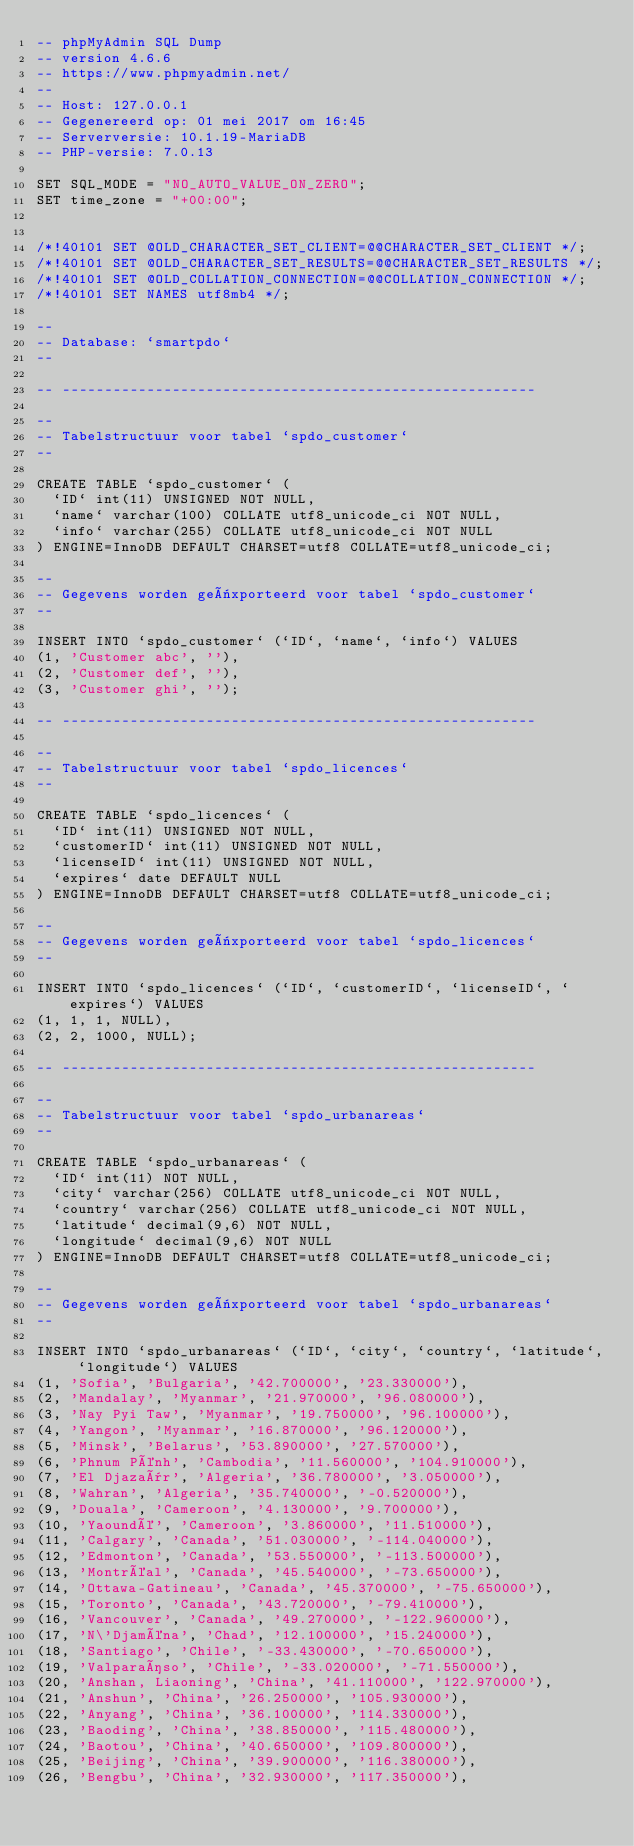<code> <loc_0><loc_0><loc_500><loc_500><_SQL_>-- phpMyAdmin SQL Dump
-- version 4.6.6
-- https://www.phpmyadmin.net/
--
-- Host: 127.0.0.1
-- Gegenereerd op: 01 mei 2017 om 16:45
-- Serverversie: 10.1.19-MariaDB
-- PHP-versie: 7.0.13

SET SQL_MODE = "NO_AUTO_VALUE_ON_ZERO";
SET time_zone = "+00:00";


/*!40101 SET @OLD_CHARACTER_SET_CLIENT=@@CHARACTER_SET_CLIENT */;
/*!40101 SET @OLD_CHARACTER_SET_RESULTS=@@CHARACTER_SET_RESULTS */;
/*!40101 SET @OLD_COLLATION_CONNECTION=@@COLLATION_CONNECTION */;
/*!40101 SET NAMES utf8mb4 */;

--
-- Database: `smartpdo`
--

-- --------------------------------------------------------

--
-- Tabelstructuur voor tabel `spdo_customer`
--

CREATE TABLE `spdo_customer` (
  `ID` int(11) UNSIGNED NOT NULL,
  `name` varchar(100) COLLATE utf8_unicode_ci NOT NULL,
  `info` varchar(255) COLLATE utf8_unicode_ci NOT NULL
) ENGINE=InnoDB DEFAULT CHARSET=utf8 COLLATE=utf8_unicode_ci;

--
-- Gegevens worden geëxporteerd voor tabel `spdo_customer`
--

INSERT INTO `spdo_customer` (`ID`, `name`, `info`) VALUES
(1, 'Customer abc', ''),
(2, 'Customer def', ''),
(3, 'Customer ghi', '');

-- --------------------------------------------------------

--
-- Tabelstructuur voor tabel `spdo_licences`
--

CREATE TABLE `spdo_licences` (
  `ID` int(11) UNSIGNED NOT NULL,
  `customerID` int(11) UNSIGNED NOT NULL,
  `licenseID` int(11) UNSIGNED NOT NULL,
  `expires` date DEFAULT NULL
) ENGINE=InnoDB DEFAULT CHARSET=utf8 COLLATE=utf8_unicode_ci;

--
-- Gegevens worden geëxporteerd voor tabel `spdo_licences`
--

INSERT INTO `spdo_licences` (`ID`, `customerID`, `licenseID`, `expires`) VALUES
(1, 1, 1, NULL),
(2, 2, 1000, NULL);

-- --------------------------------------------------------

--
-- Tabelstructuur voor tabel `spdo_urbanareas`
--

CREATE TABLE `spdo_urbanareas` (
  `ID` int(11) NOT NULL,
  `city` varchar(256) COLLATE utf8_unicode_ci NOT NULL,
  `country` varchar(256) COLLATE utf8_unicode_ci NOT NULL,
  `latitude` decimal(9,6) NOT NULL,
  `longitude` decimal(9,6) NOT NULL
) ENGINE=InnoDB DEFAULT CHARSET=utf8 COLLATE=utf8_unicode_ci;

--
-- Gegevens worden geëxporteerd voor tabel `spdo_urbanareas`
--

INSERT INTO `spdo_urbanareas` (`ID`, `city`, `country`, `latitude`, `longitude`) VALUES
(1, 'Sofia', 'Bulgaria', '42.700000', '23.330000'),
(2, 'Mandalay', 'Myanmar', '21.970000', '96.080000'),
(3, 'Nay Pyi Taw', 'Myanmar', '19.750000', '96.100000'),
(4, 'Yangon', 'Myanmar', '16.870000', '96.120000'),
(5, 'Minsk', 'Belarus', '53.890000', '27.570000'),
(6, 'Phnum Pénh', 'Cambodia', '11.560000', '104.910000'),
(7, 'El Djazaïr', 'Algeria', '36.780000', '3.050000'),
(8, 'Wahran', 'Algeria', '35.740000', '-0.520000'),
(9, 'Douala', 'Cameroon', '4.130000', '9.700000'),
(10, 'Yaoundé', 'Cameroon', '3.860000', '11.510000'),
(11, 'Calgary', 'Canada', '51.030000', '-114.040000'),
(12, 'Edmonton', 'Canada', '53.550000', '-113.500000'),
(13, 'Montréal', 'Canada', '45.540000', '-73.650000'),
(14, 'Ottawa-Gatineau', 'Canada', '45.370000', '-75.650000'),
(15, 'Toronto', 'Canada', '43.720000', '-79.410000'),
(16, 'Vancouver', 'Canada', '49.270000', '-122.960000'),
(17, 'N\'Djaména', 'Chad', '12.100000', '15.240000'),
(18, 'Santiago', 'Chile', '-33.430000', '-70.650000'),
(19, 'Valparaíso', 'Chile', '-33.020000', '-71.550000'),
(20, 'Anshan, Liaoning', 'China', '41.110000', '122.970000'),
(21, 'Anshun', 'China', '26.250000', '105.930000'),
(22, 'Anyang', 'China', '36.100000', '114.330000'),
(23, 'Baoding', 'China', '38.850000', '115.480000'),
(24, 'Baotou', 'China', '40.650000', '109.800000'),
(25, 'Beijing', 'China', '39.900000', '116.380000'),
(26, 'Bengbu', 'China', '32.930000', '117.350000'),</code> 